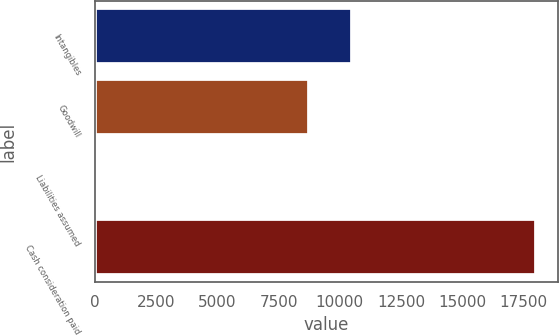Convert chart. <chart><loc_0><loc_0><loc_500><loc_500><bar_chart><fcel>Intangibles<fcel>Goodwill<fcel>Liabilities assumed<fcel>Cash consideration paid<nl><fcel>10517<fcel>8730<fcel>130<fcel>18000<nl></chart> 